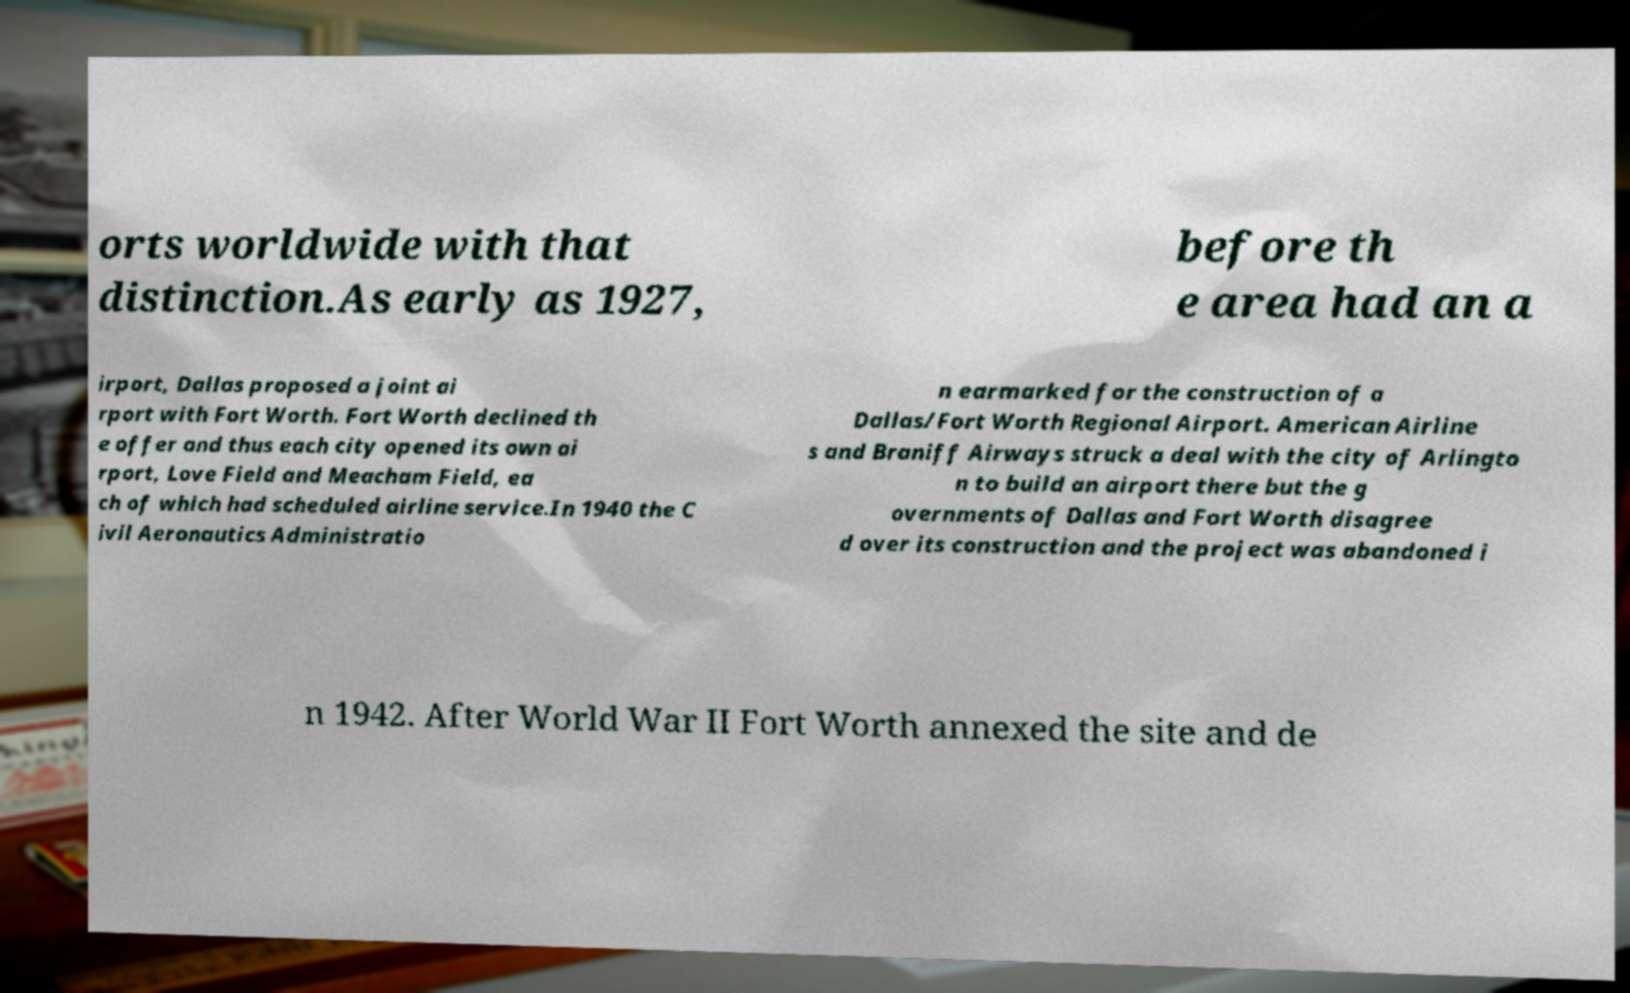Can you accurately transcribe the text from the provided image for me? orts worldwide with that distinction.As early as 1927, before th e area had an a irport, Dallas proposed a joint ai rport with Fort Worth. Fort Worth declined th e offer and thus each city opened its own ai rport, Love Field and Meacham Field, ea ch of which had scheduled airline service.In 1940 the C ivil Aeronautics Administratio n earmarked for the construction of a Dallas/Fort Worth Regional Airport. American Airline s and Braniff Airways struck a deal with the city of Arlingto n to build an airport there but the g overnments of Dallas and Fort Worth disagree d over its construction and the project was abandoned i n 1942. After World War II Fort Worth annexed the site and de 